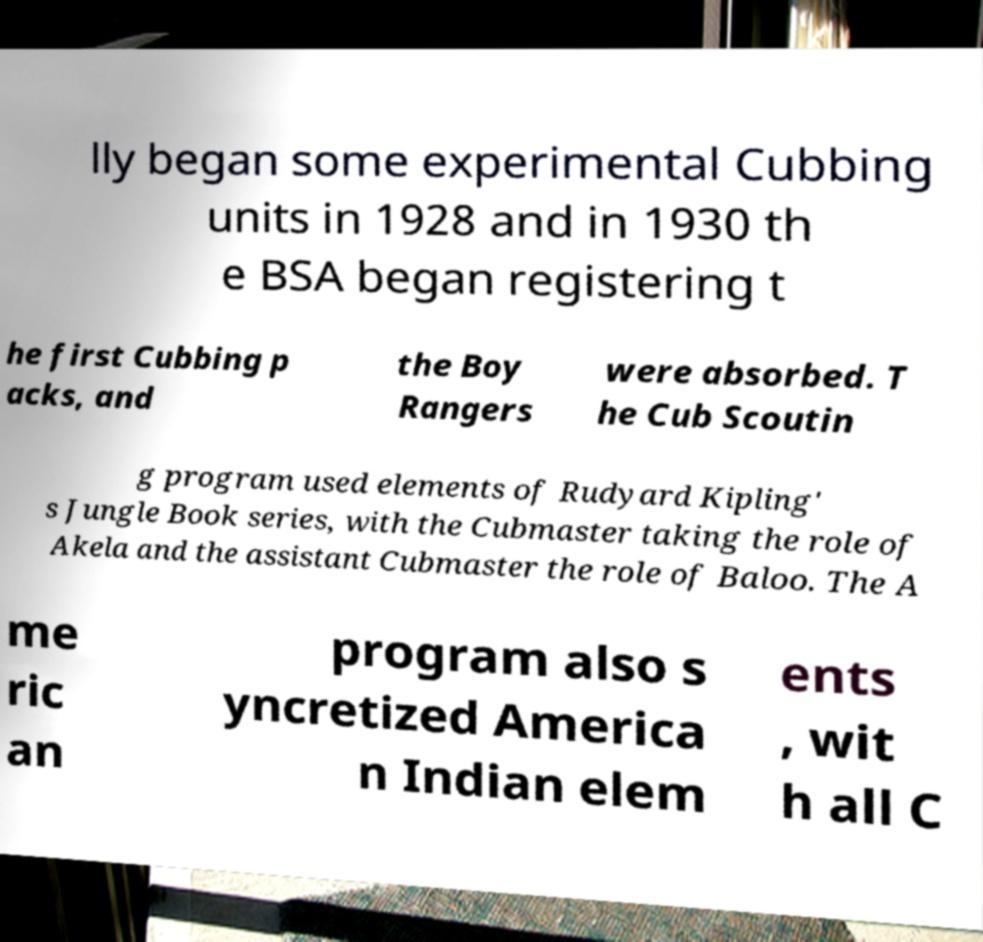Can you accurately transcribe the text from the provided image for me? lly began some experimental Cubbing units in 1928 and in 1930 th e BSA began registering t he first Cubbing p acks, and the Boy Rangers were absorbed. T he Cub Scoutin g program used elements of Rudyard Kipling' s Jungle Book series, with the Cubmaster taking the role of Akela and the assistant Cubmaster the role of Baloo. The A me ric an program also s yncretized America n Indian elem ents , wit h all C 